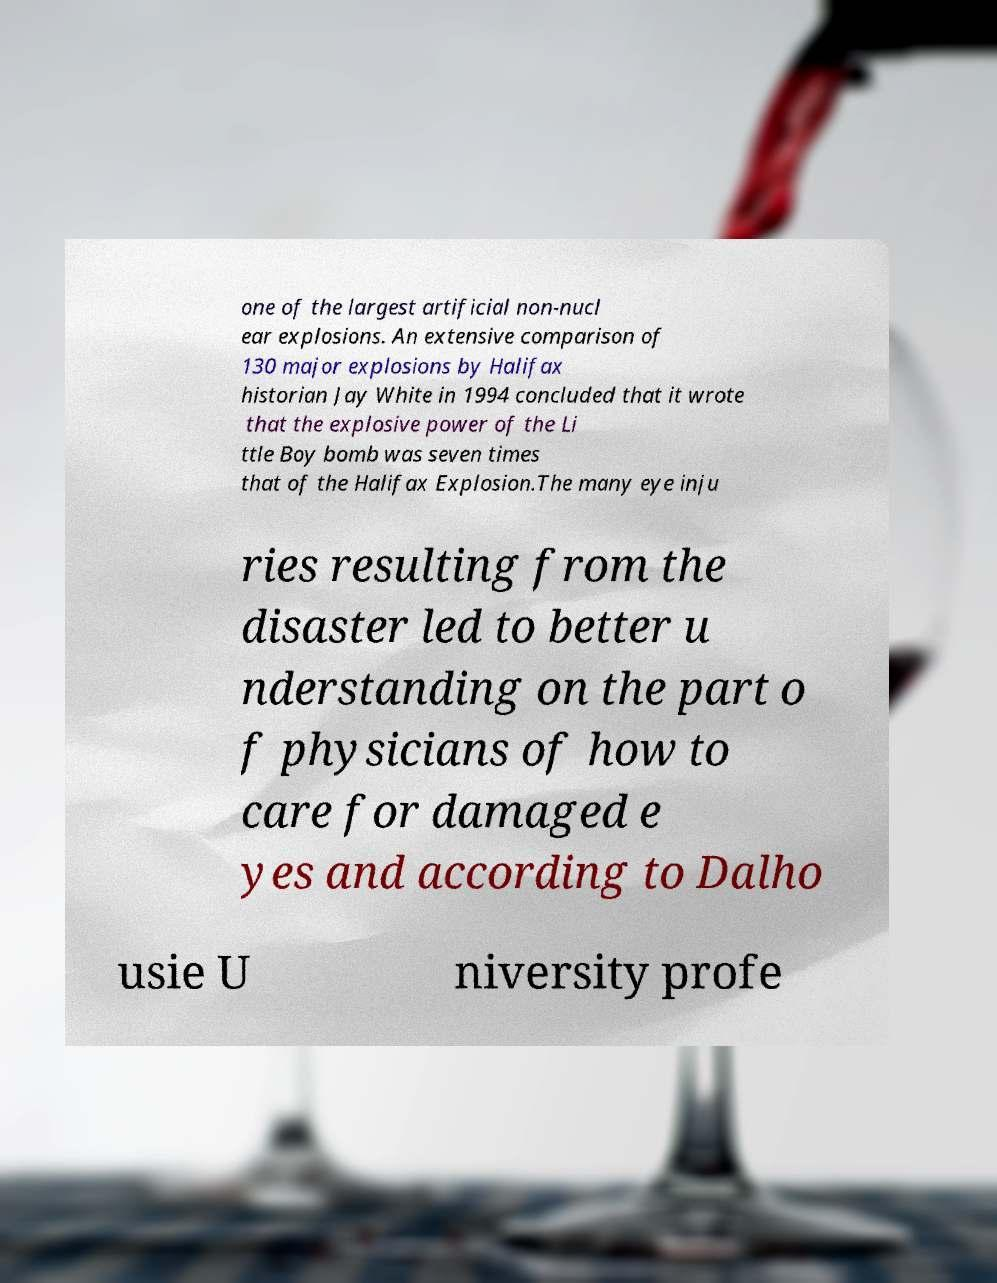I need the written content from this picture converted into text. Can you do that? one of the largest artificial non-nucl ear explosions. An extensive comparison of 130 major explosions by Halifax historian Jay White in 1994 concluded that it wrote that the explosive power of the Li ttle Boy bomb was seven times that of the Halifax Explosion.The many eye inju ries resulting from the disaster led to better u nderstanding on the part o f physicians of how to care for damaged e yes and according to Dalho usie U niversity profe 